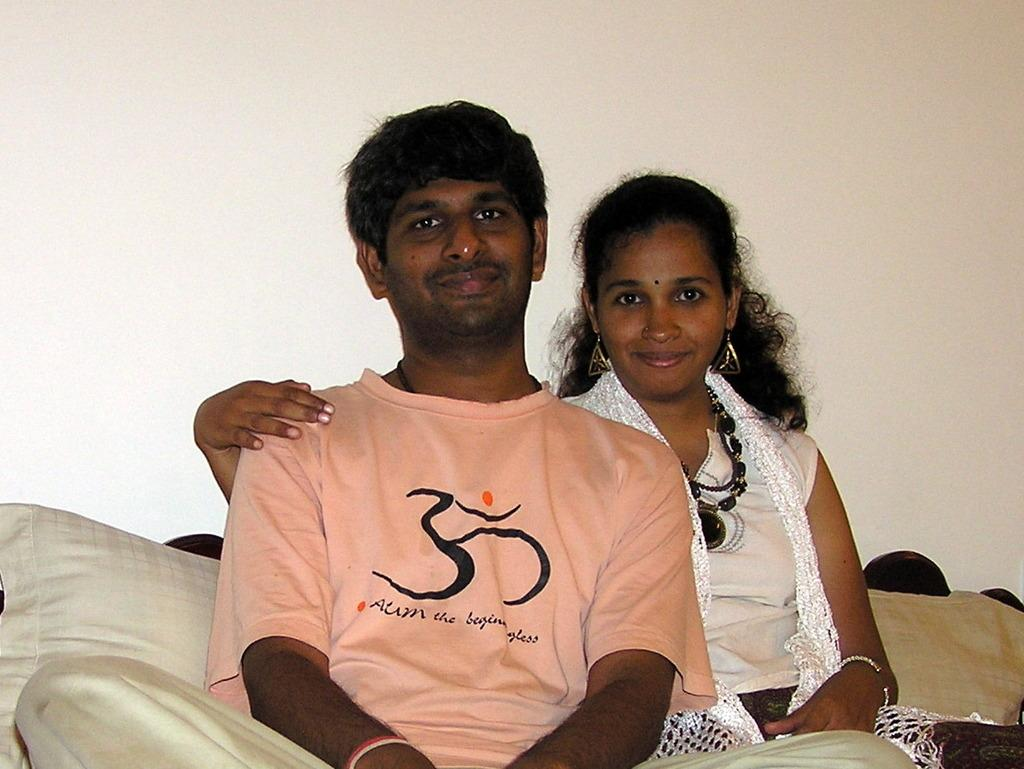How many people are in the image? There are two people in the image, a man and a woman. What are the man and woman doing in the image? Both the man and woman are sitting on a couch. What color is the couch they are sitting on? The couch is cream in color. What can be seen in the background of the image? There is a cream-colored wall in the background of the image. What type of flower is the minister holding in the image? There is no minister or flower present in the image. Can you hear the couple laughing in the image? The image is a still photograph, so there is no sound or laughter present. 